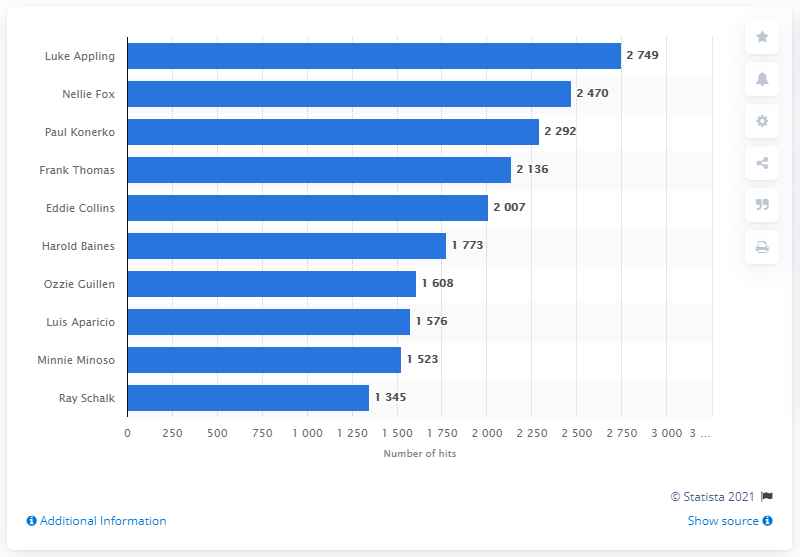Identify some key points in this picture. As of my knowledge cutoff date of September 2021, the Chicago White Sox franchise history record for most hits belongs to Luke Appling, with a total of 2,335 hits during his playing career with the team. 